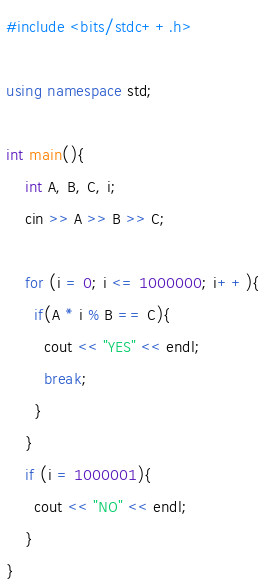Convert code to text. <code><loc_0><loc_0><loc_500><loc_500><_C++_>#include <bits/stdc++.h>

using namespace std;
 
int main(){
    int A, B, C, i;
    cin >> A >> B >> C;

    for (i = 0; i <= 1000000; i++){
      if(A * i % B == C){
        cout << "YES" << endl;
        break;
      }
    }
    if (i = 1000001){
      cout << "NO" << endl;
    }
}</code> 